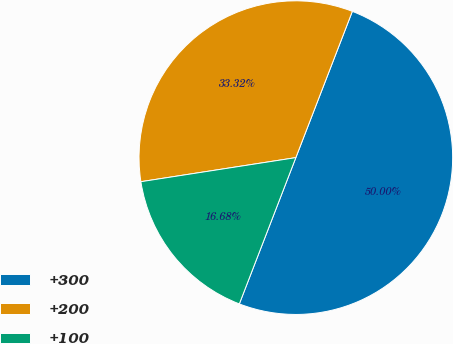<chart> <loc_0><loc_0><loc_500><loc_500><pie_chart><fcel>+300<fcel>+200<fcel>+100<nl><fcel>50.0%<fcel>33.32%<fcel>16.68%<nl></chart> 